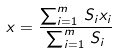Convert formula to latex. <formula><loc_0><loc_0><loc_500><loc_500>x = \frac { \sum _ { i = 1 } ^ { m } \, S _ { i } x _ { i } } { \sum _ { i = 1 } ^ { m } \, S _ { i } }</formula> 